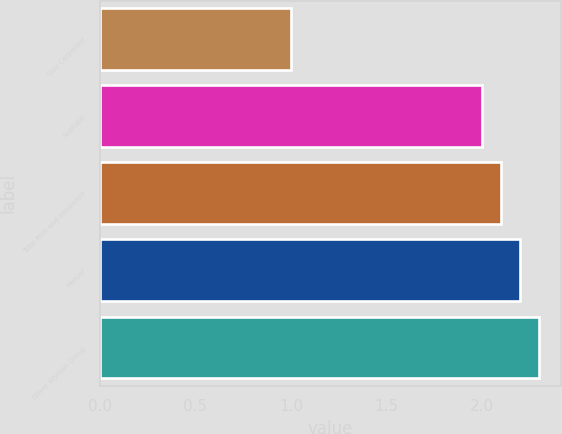Convert chart to OTSL. <chart><loc_0><loc_0><loc_500><loc_500><bar_chart><fcel>Guy Carpenter<fcel>Subtotal<fcel>Total Risk and Insurance<fcel>Mercer<fcel>Oliver Wyman Group<nl><fcel>1<fcel>2<fcel>2.1<fcel>2.2<fcel>2.3<nl></chart> 